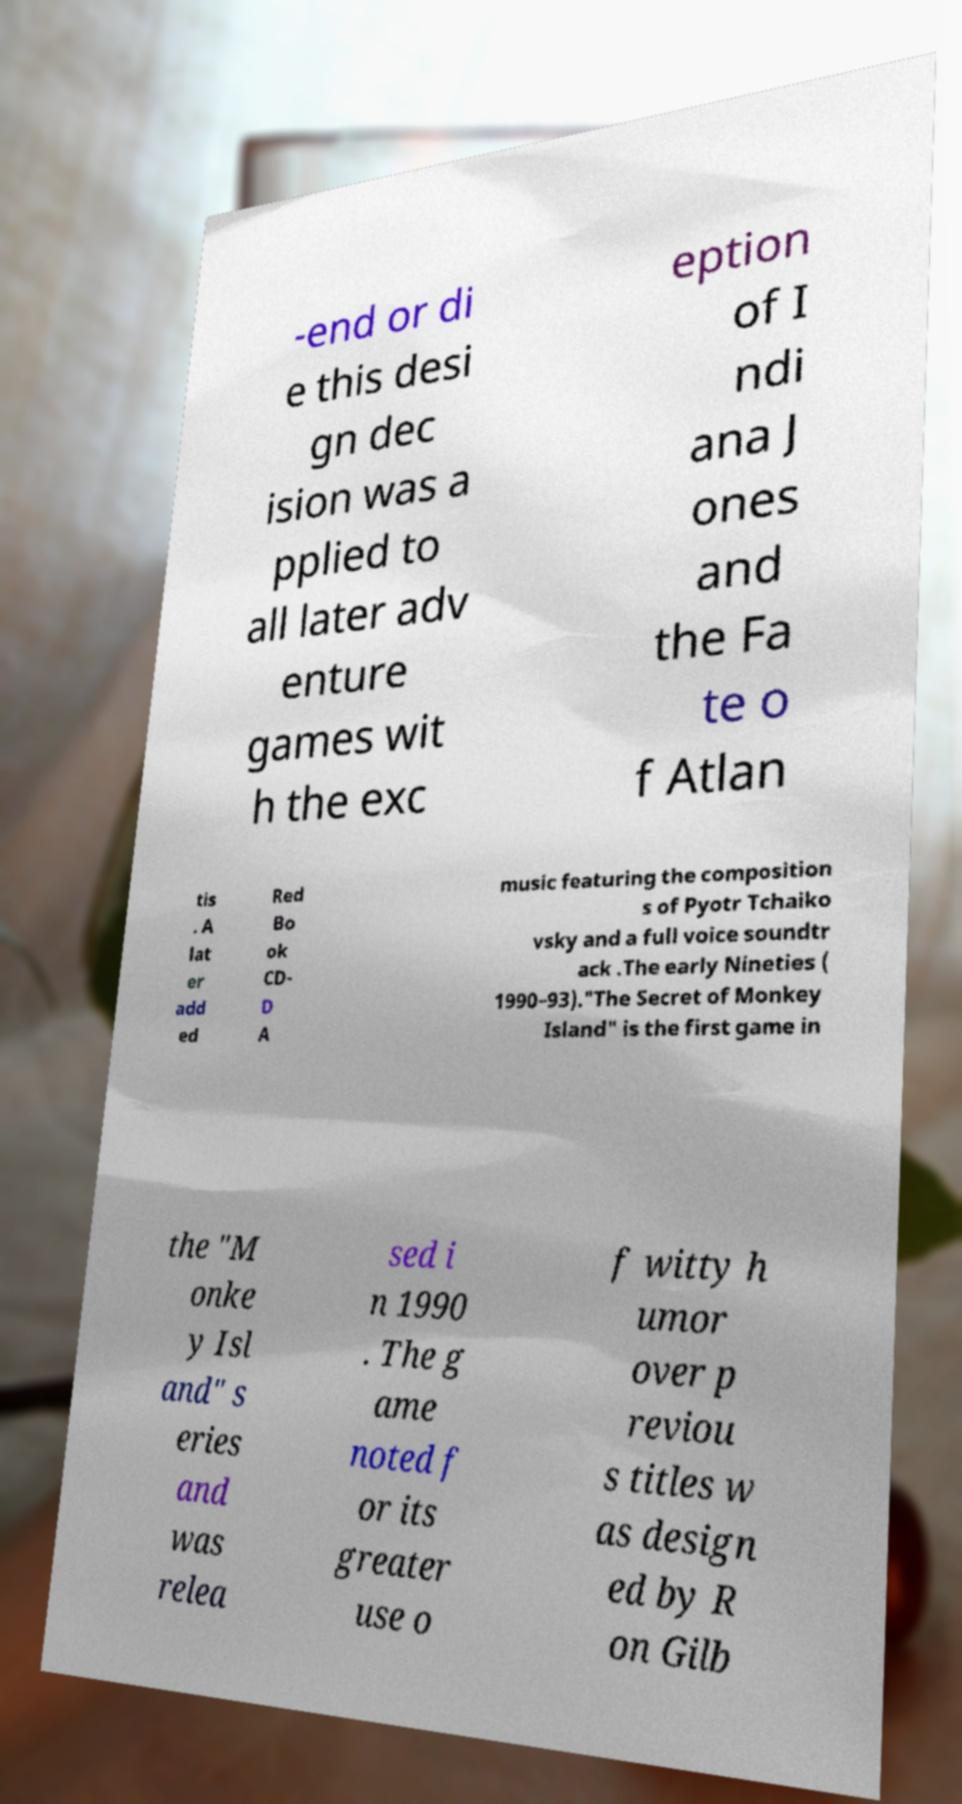Can you read and provide the text displayed in the image?This photo seems to have some interesting text. Can you extract and type it out for me? -end or di e this desi gn dec ision was a pplied to all later adv enture games wit h the exc eption of I ndi ana J ones and the Fa te o f Atlan tis . A lat er add ed Red Bo ok CD- D A music featuring the composition s of Pyotr Tchaiko vsky and a full voice soundtr ack .The early Nineties ( 1990–93)."The Secret of Monkey Island" is the first game in the "M onke y Isl and" s eries and was relea sed i n 1990 . The g ame noted f or its greater use o f witty h umor over p reviou s titles w as design ed by R on Gilb 